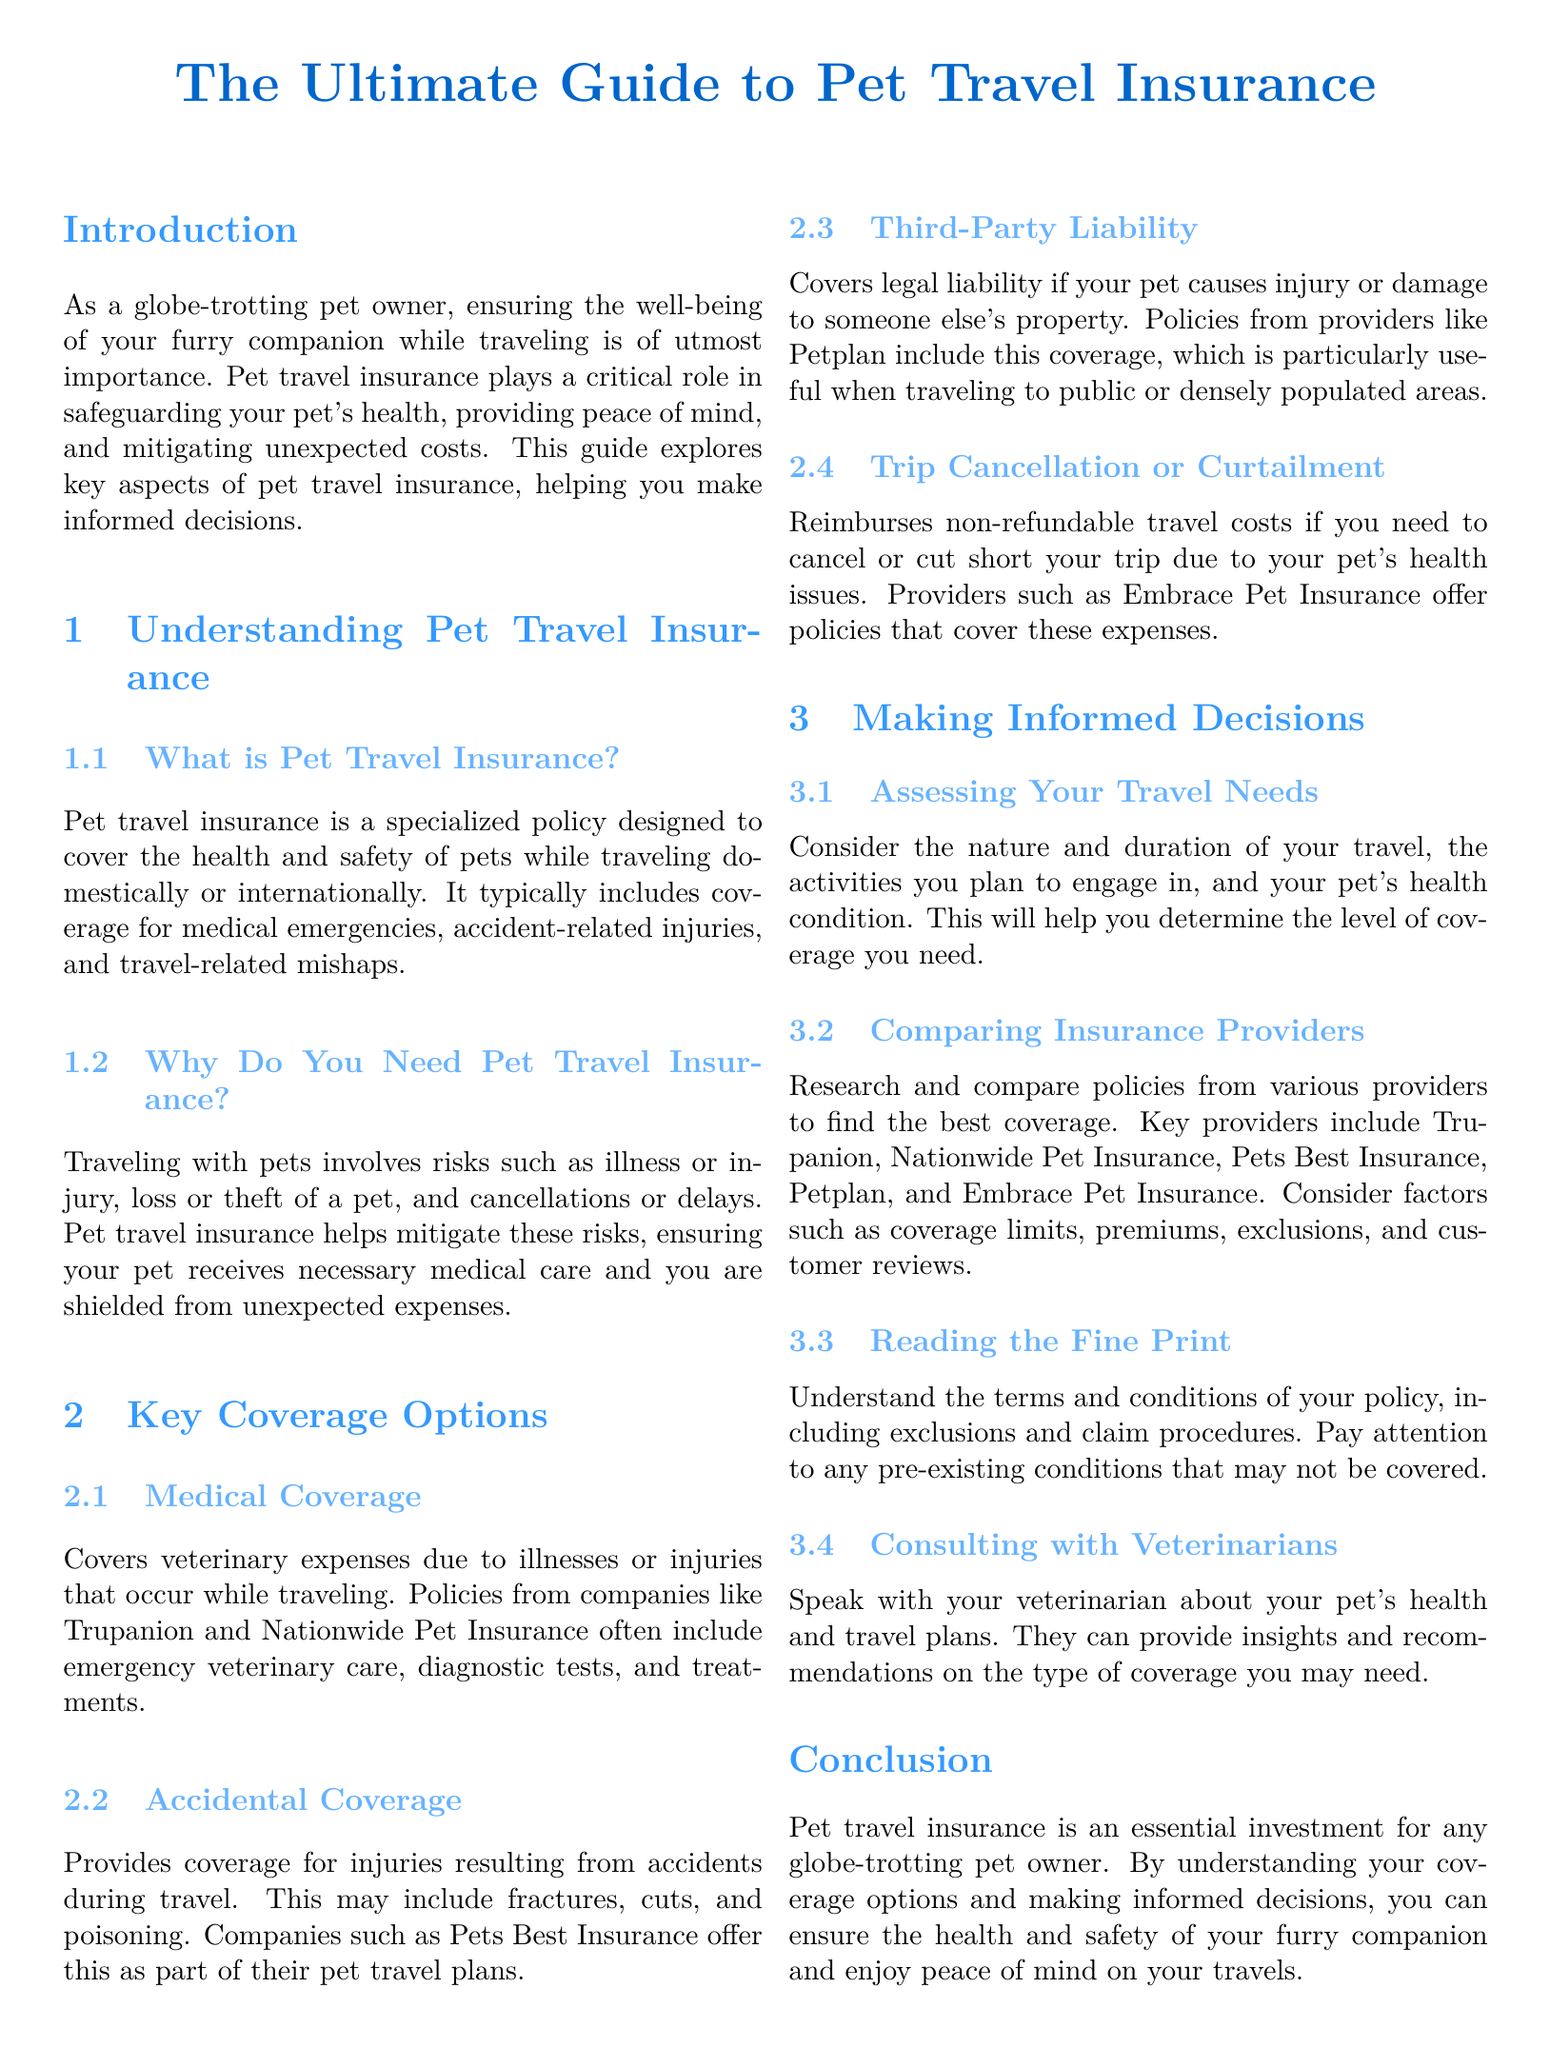What is pet travel insurance? Pet travel insurance is a specialized policy designed to cover the health and safety of pets while traveling domestically or internationally.
Answer: A specialized policy Why do you need pet travel insurance? Traveling with pets involves risks such as illness or injury, loss or theft of a pet, and cancellations or delays.
Answer: To mitigate risks What type of coverage includes emergency veterinary care? Medical coverage covers veterinary expenses due to illnesses or injuries that occur while traveling.
Answer: Medical coverage Which company offers accidental coverage as part of their plans? Pets Best Insurance offers accidental coverage as part of their pet travel plans.
Answer: Pets Best Insurance What does trip cancellation coverage reimburse? Trip Cancellation or Curtailment reimburses non-refundable travel costs if you need to cancel or cut short your trip due to your pet's health issues.
Answer: Non-refundable travel costs What should you consider to assess your travel needs? Consider the nature and duration of your travel, the activities you plan to engage in, and your pet's health condition.
Answer: Nature and duration of travel How many key providers are mentioned for comparing insurance? Five key providers are mentioned for comparing insurance: Trupanion, Nationwide Pet Insurance, Pets Best Insurance, Petplan, Embrace Pet Insurance.
Answer: Five What is important to understand in the fine print of an insurance policy? Understand the terms and conditions of your policy, including exclusions and claim procedures.
Answer: Terms and conditions Who can provide insights on the type of pet coverage you may need? Speak with your veterinarian about your pet's health and travel plans for insights and recommendations.
Answer: Your veterinarian 